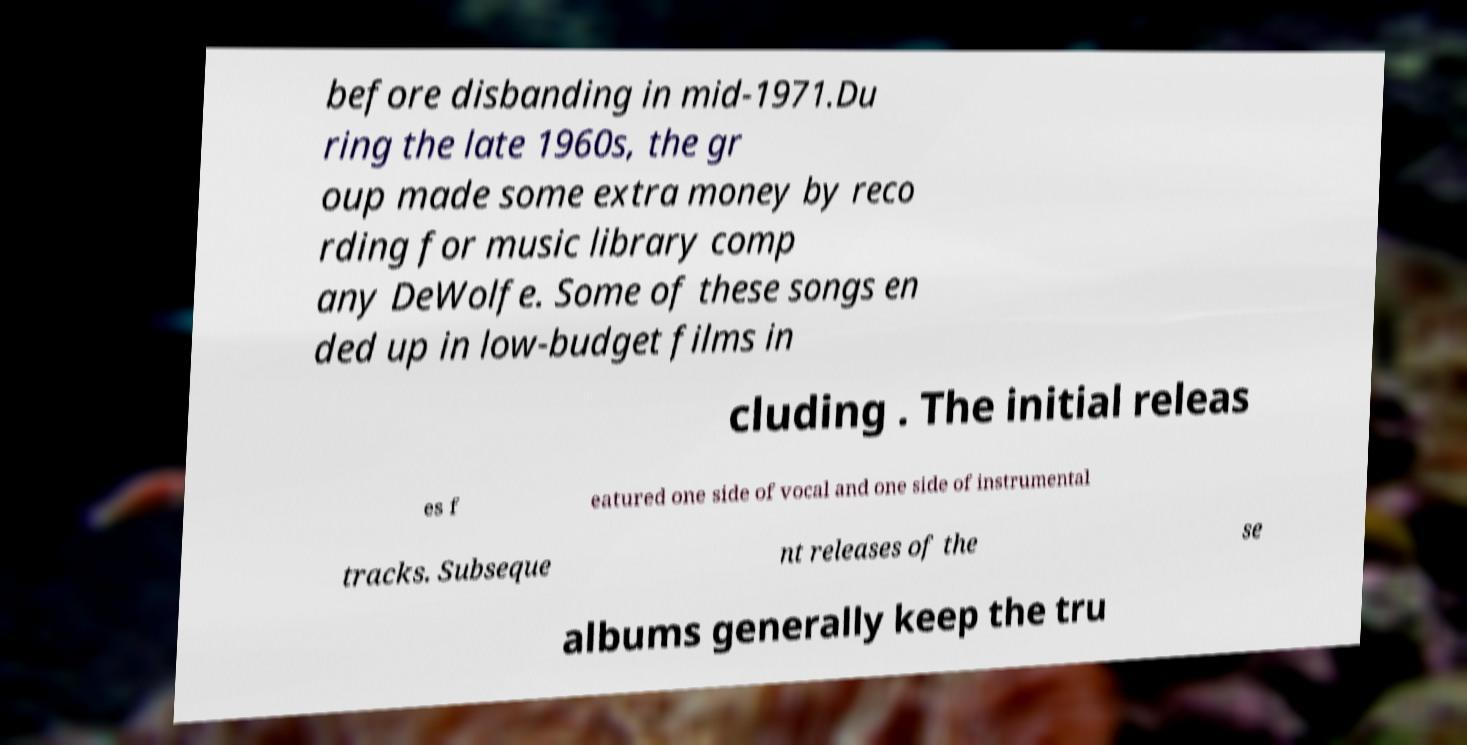For documentation purposes, I need the text within this image transcribed. Could you provide that? before disbanding in mid-1971.Du ring the late 1960s, the gr oup made some extra money by reco rding for music library comp any DeWolfe. Some of these songs en ded up in low-budget films in cluding . The initial releas es f eatured one side of vocal and one side of instrumental tracks. Subseque nt releases of the se albums generally keep the tru 